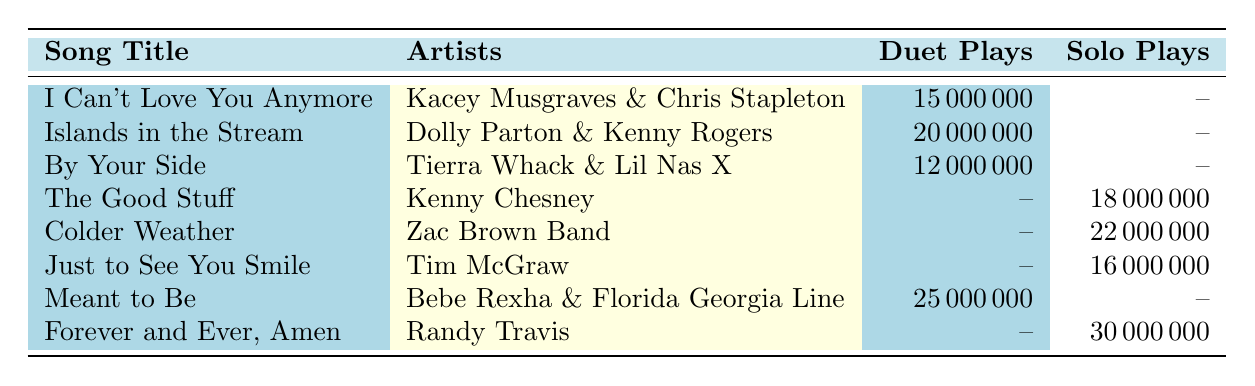What's the total number of plays for the song "Meant to Be"? The data shows that "Meant to Be" has 25,000,000 duet plays and no solo plays. Therefore, the total plays for this song is simply the duet plays.
Answer: 25,000,000 What is the total number of solo plays for the song "Colder Weather"? The table indicates that "Colder Weather" has 22,000,000 solo plays and no duet plays, so the total number of solo plays is 22,000,000.
Answer: 22,000,000 True or False: "Kacey Musgraves & Chris Stapleton" had more duet plays than "Kenny Chesney" had solo plays. Kacey Musgraves & Chris Stapleton had 15,000,000 duet plays, while Kenny Chesney had 18,000,000 solo plays. Since 15,000,000 is less than 18,000,000, the statement is false.
Answer: False What is the average number of duet plays for the songs listed? The duet plays for the songs are 15,000,000; 20,000,000; 12,000,000; and 25,000,000. The total is 72,000,000 from 4 songs, so the average is 72,000,000 / 4 = 18,000,000.
Answer: 18,000,000 Which song has the highest duet plays, and what is the number of plays? The data shows that "Meant to Be" has the highest duet plays with 25,000,000.
Answer: Meant to Be, 25,000,000 What is the total number of plays (duet + solo) for all songs represented in the table? The total plays include 15,000,000 + 20,000,000 + 12,000,000 (duet plays) for a total of 47,000,000, and 18,000,000 + 22,000,000 + 16,000,000 + 30,000,000 (solo plays) for 86,000,000. The overall total is 47,000,000 + 86,000,000 = 133,000,000.
Answer: 133,000,000 Which artists' song had solo plays listed in the table? The solo plays listed in the table are from songs by Kenny Chesney, Zac Brown Band, Tim McGraw, and Randy Travis.
Answer: Kenny Chesney, Zac Brown Band, Tim McGraw, Randy Travis Is there any song that has both duet and solo plays listed? According to the table, none of the songs have both duet and solo plays listed; either duet or solo plays are recorded for each song.
Answer: No 